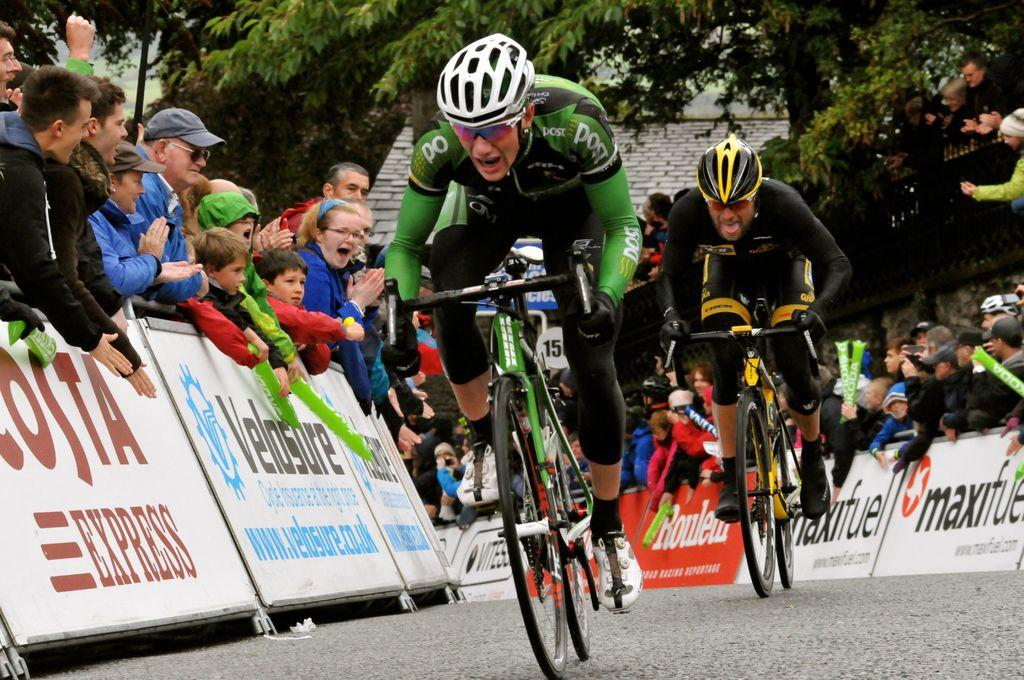How many people are in the image? There are two persons in the image. What are the persons wearing on their heads? Both persons are wearing helmets. What activity are the persons engaged in? The persons are riding bicycles. What is at the bottom of the image? There is a road at the bottom of the image. What can be seen in the background of the image? There are many people in the background of the image. What type of vegetation is visible to the right of the image? There are trees to the right of the image. What type of gate can be seen in the image? There is no gate present in the image; it features two persons riding bicycles with trees in the background. 